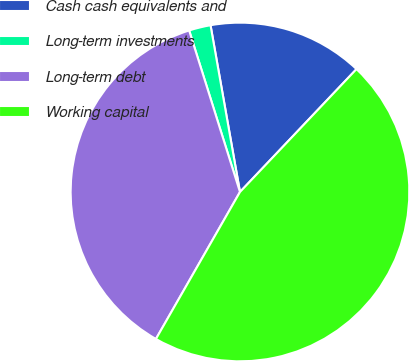Convert chart. <chart><loc_0><loc_0><loc_500><loc_500><pie_chart><fcel>Cash cash equivalents and<fcel>Long-term investments<fcel>Long-term debt<fcel>Working capital<nl><fcel>14.86%<fcel>2.07%<fcel>36.88%<fcel>46.19%<nl></chart> 